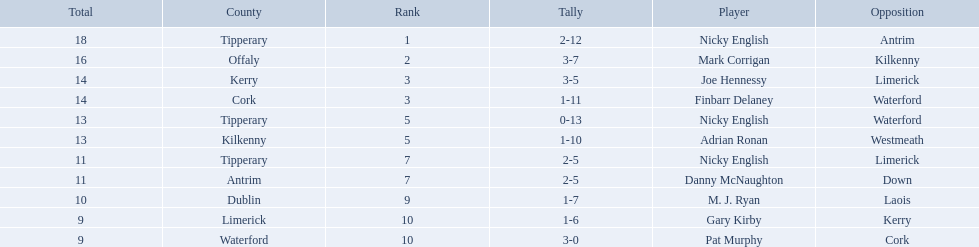Which of the following players were ranked in the bottom 5? Nicky English, Danny McNaughton, M. J. Ryan, Gary Kirby, Pat Murphy. Of these, whose tallies were not 2-5? M. J. Ryan, Gary Kirby, Pat Murphy. From the above three, which one scored more than 9 total points? M. J. Ryan. 